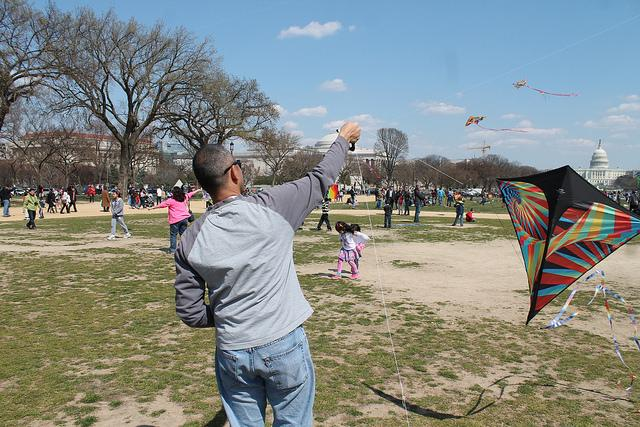Where would more well known government workers work here? Please explain your reasoning. rightmost building. The capitol building is on the far right. congress people work in this building. 